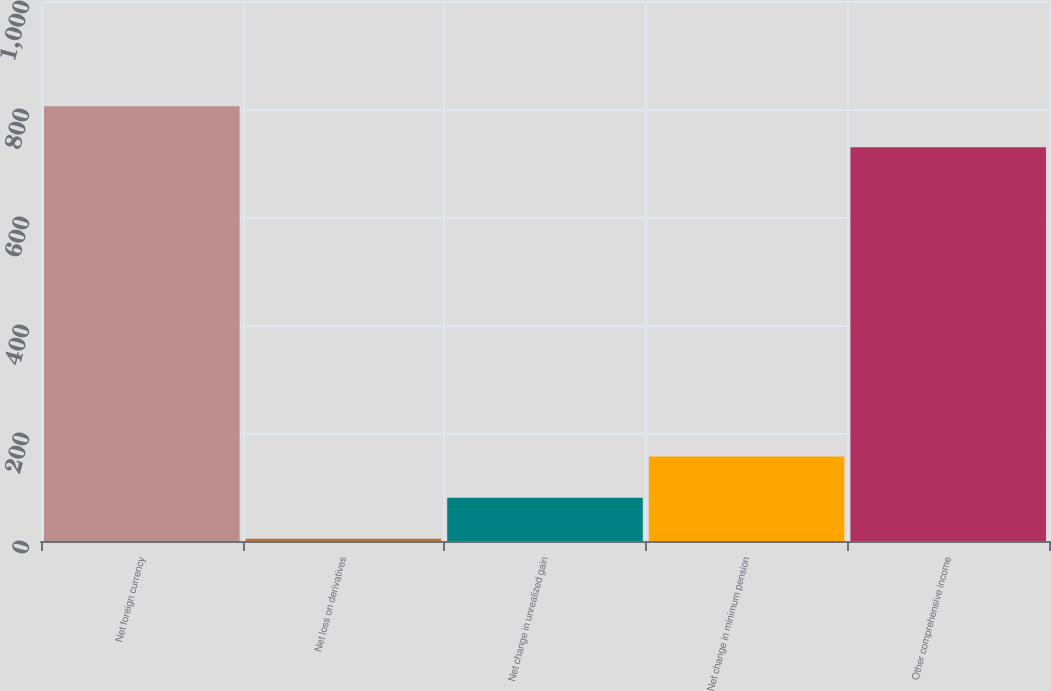Convert chart. <chart><loc_0><loc_0><loc_500><loc_500><bar_chart><fcel>Net foreign currency<fcel>Net loss on derivatives<fcel>Net change in unrealized gain<fcel>Net change in minimum pension<fcel>Other comprehensive income<nl><fcel>805.2<fcel>4<fcel>80.2<fcel>156.4<fcel>729<nl></chart> 